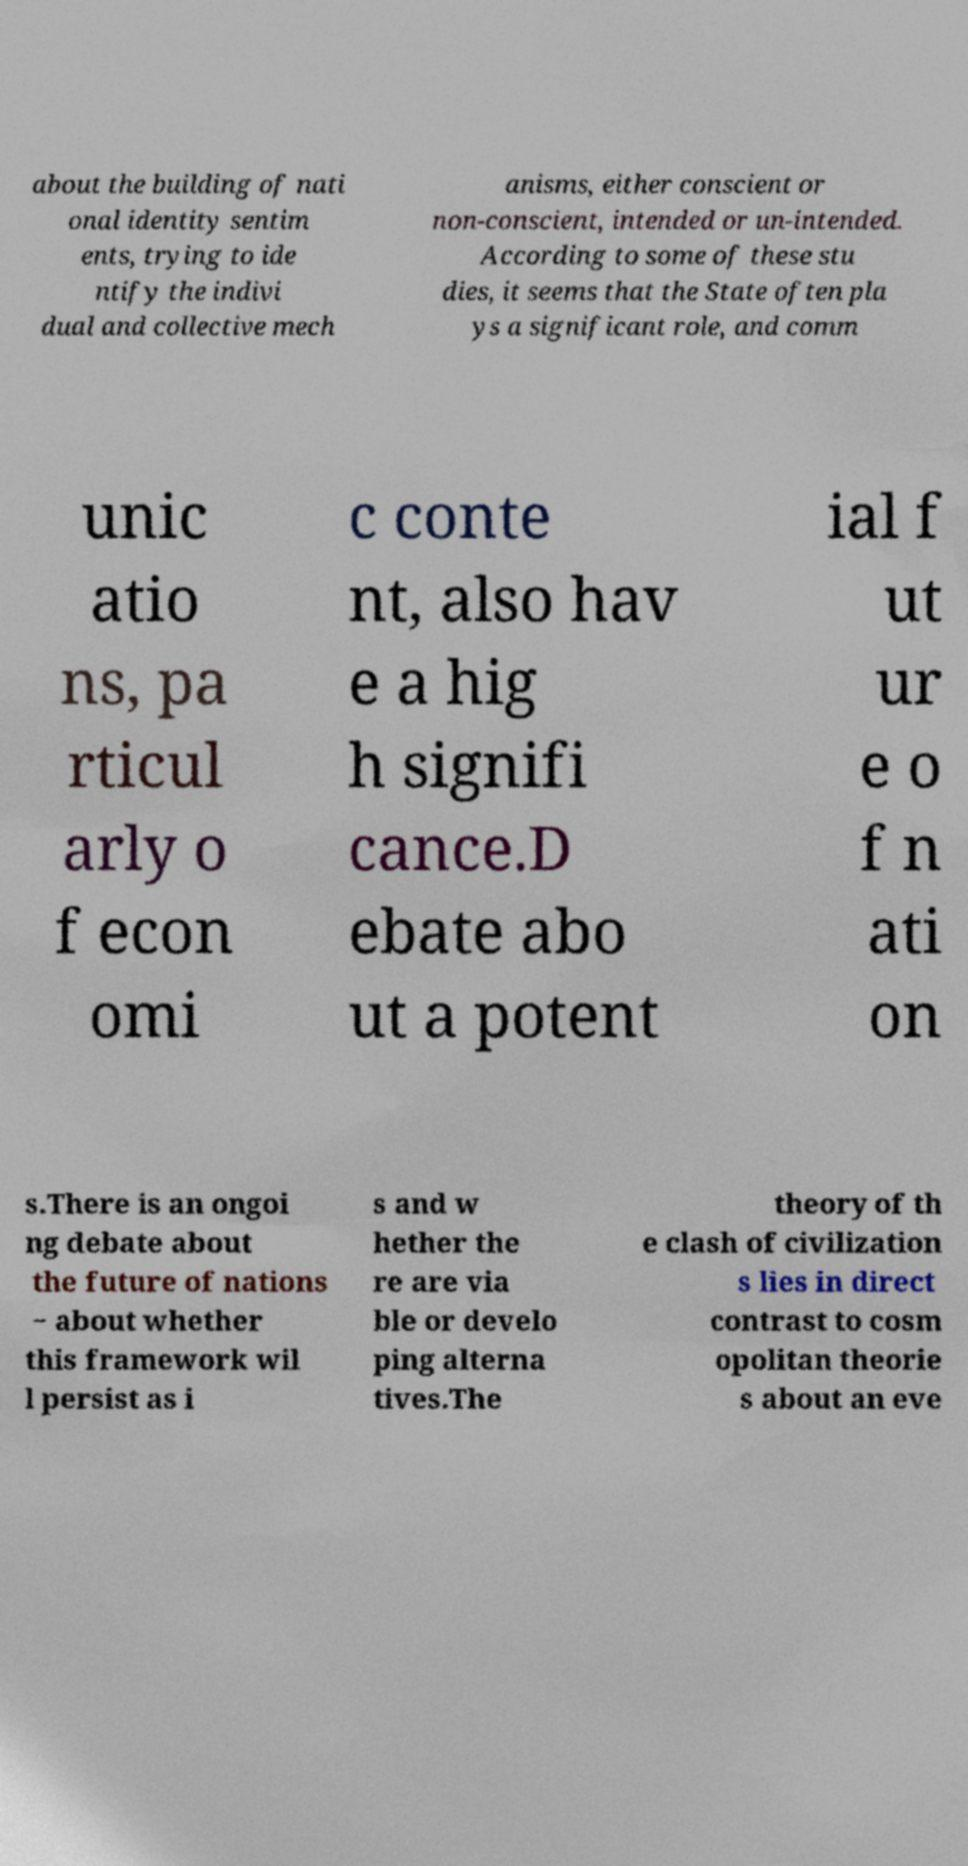Can you read and provide the text displayed in the image?This photo seems to have some interesting text. Can you extract and type it out for me? about the building of nati onal identity sentim ents, trying to ide ntify the indivi dual and collective mech anisms, either conscient or non-conscient, intended or un-intended. According to some of these stu dies, it seems that the State often pla ys a significant role, and comm unic atio ns, pa rticul arly o f econ omi c conte nt, also hav e a hig h signifi cance.D ebate abo ut a potent ial f ut ur e o f n ati on s.There is an ongoi ng debate about the future of nations − about whether this framework wil l persist as i s and w hether the re are via ble or develo ping alterna tives.The theory of th e clash of civilization s lies in direct contrast to cosm opolitan theorie s about an eve 